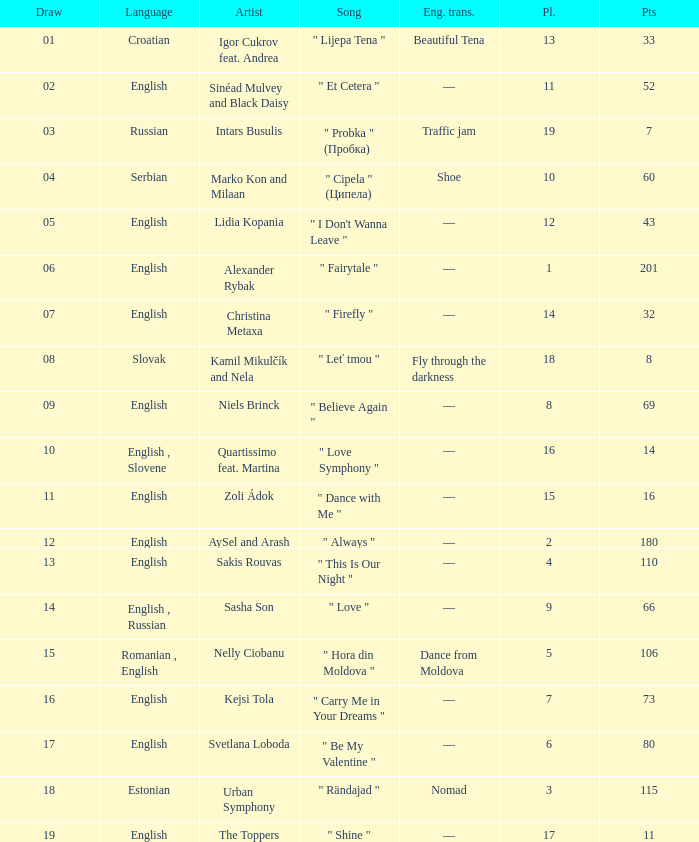What is the average Points when the artist is kamil mikulčík and nela, and the Place is larger than 18? None. 